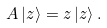Convert formula to latex. <formula><loc_0><loc_0><loc_500><loc_500>A \left | z \right \rangle = z \left | z \right \rangle .</formula> 